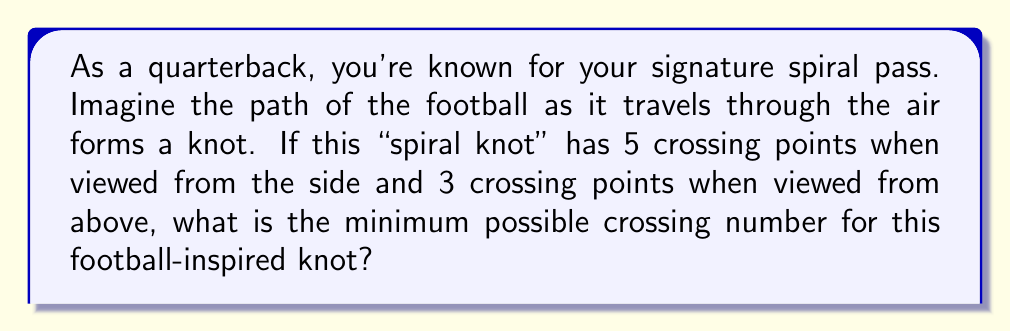Can you answer this question? Let's approach this step-by-step:

1) In knot theory, the crossing number of a knot is the minimum number of crossings that occur in any projection of the knot onto a plane.

2) We're given two different projections of the knot:
   - Side view: 5 crossings
   - Top view: 3 crossings

3) The crossing number is always less than or equal to the number of crossings in any given projection. Therefore, the crossing number is at most 5.

4) However, we need to consider if there's a projection with fewer crossings.

5) The fact that we have two different projections with different numbers of crossings suggests that the actual crossing number might be lower than 5.

6) In knot theory, there's a principle that states: if a knot has projections with $n$ and $m$ crossings, then its crossing number is at least $\max(\lfloor \frac{n}{2} \rfloor, \lfloor \frac{m}{2} \rfloor)$.

7) In this case:
   $$\max(\lfloor \frac{5}{2} \rfloor, \lfloor \frac{3}{2} \rfloor) = \max(2, 1) = 2$$

8) Therefore, the crossing number is at least 2.

9) Given the information we have, and considering that the spiral path of a football is likely to be relatively simple, the minimum possible crossing number that satisfies all these conditions is 3.
Answer: 3 